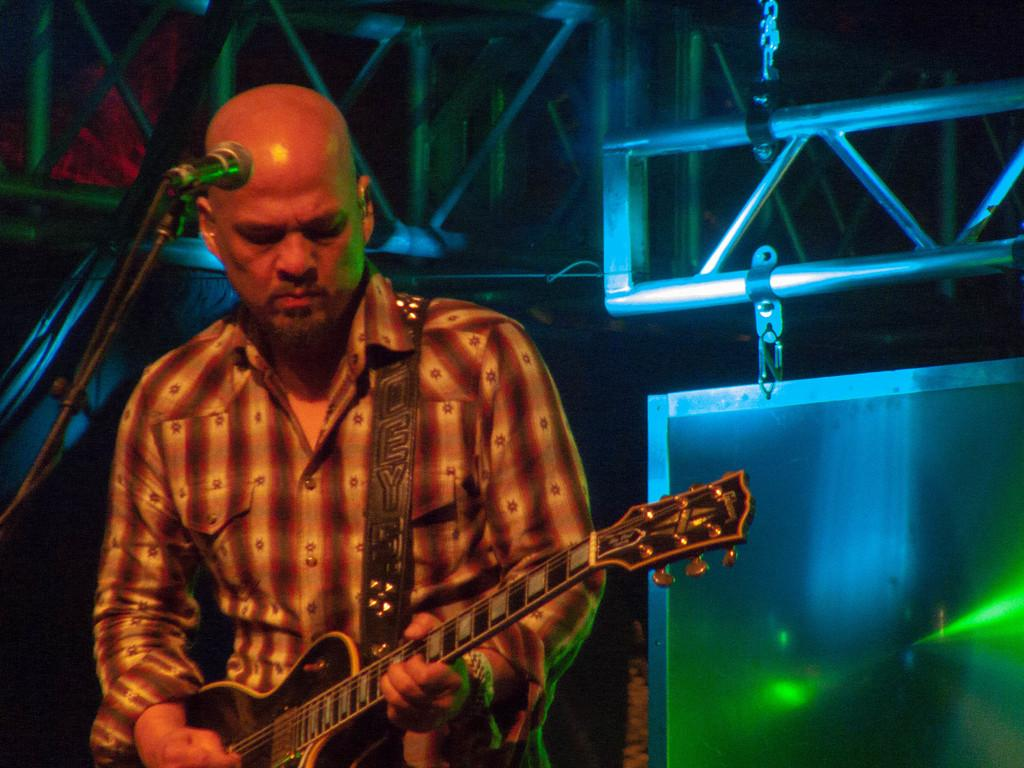What is the man in the image doing? The man is playing a guitar in the image. What object is present in the image that is typically used for amplifying sound? There is a microphone in the image, which is attached to a microphone stand. What can be seen in the background of the image? There are objects hanging in the background of the image, which appear to be made of metal. What type of structure is visible in the background of the image? There is no specific structure visible in the background of the image; it only shows hanging metal objects. What type of power source is required for the guitar to function in the image? The image does not provide information about the power source required for the guitar to function. 